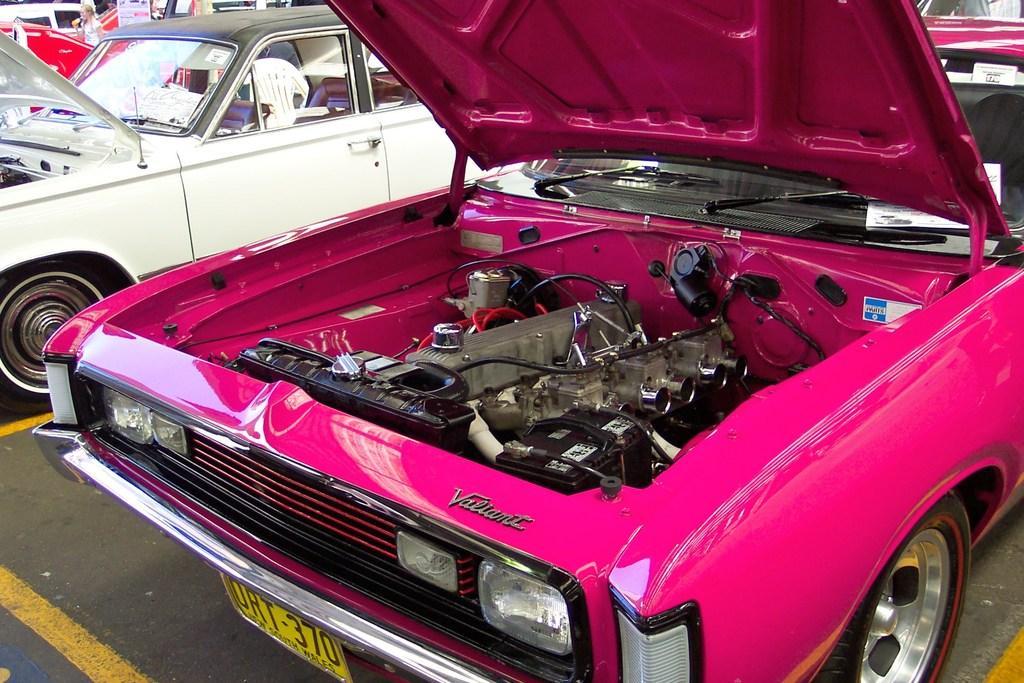How would you summarize this image in a sentence or two? This picture consists of vehicles and I can see a pink color vehicle and in the vehicle I can see a engine part and wires and name plates attached to it. 